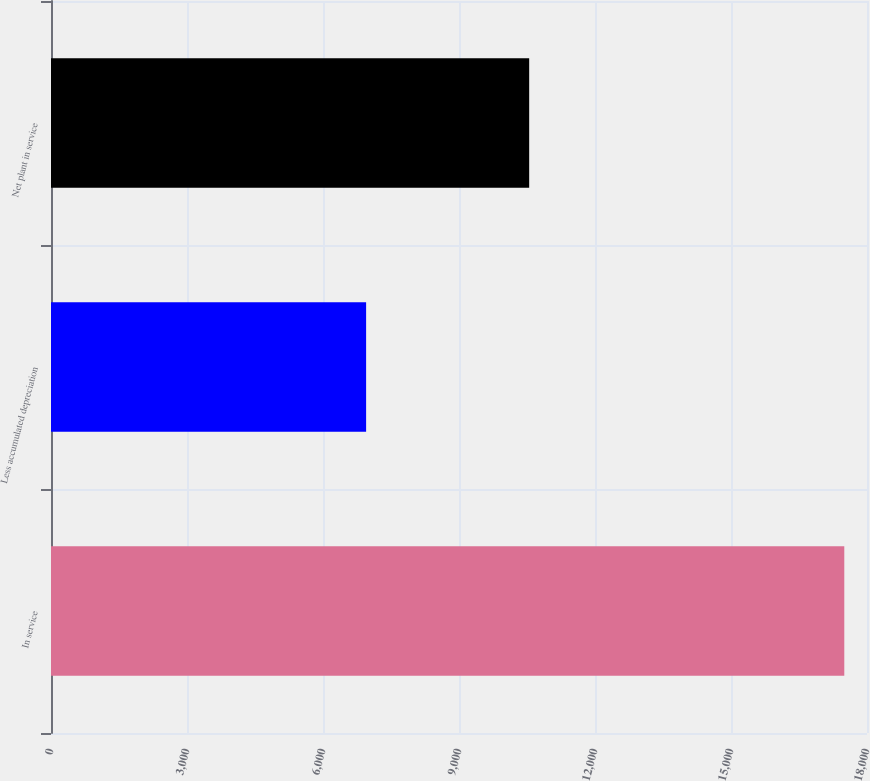Convert chart. <chart><loc_0><loc_0><loc_500><loc_500><bar_chart><fcel>In service<fcel>Less accumulated depreciation<fcel>Net plant in service<nl><fcel>17499<fcel>6951<fcel>10548<nl></chart> 